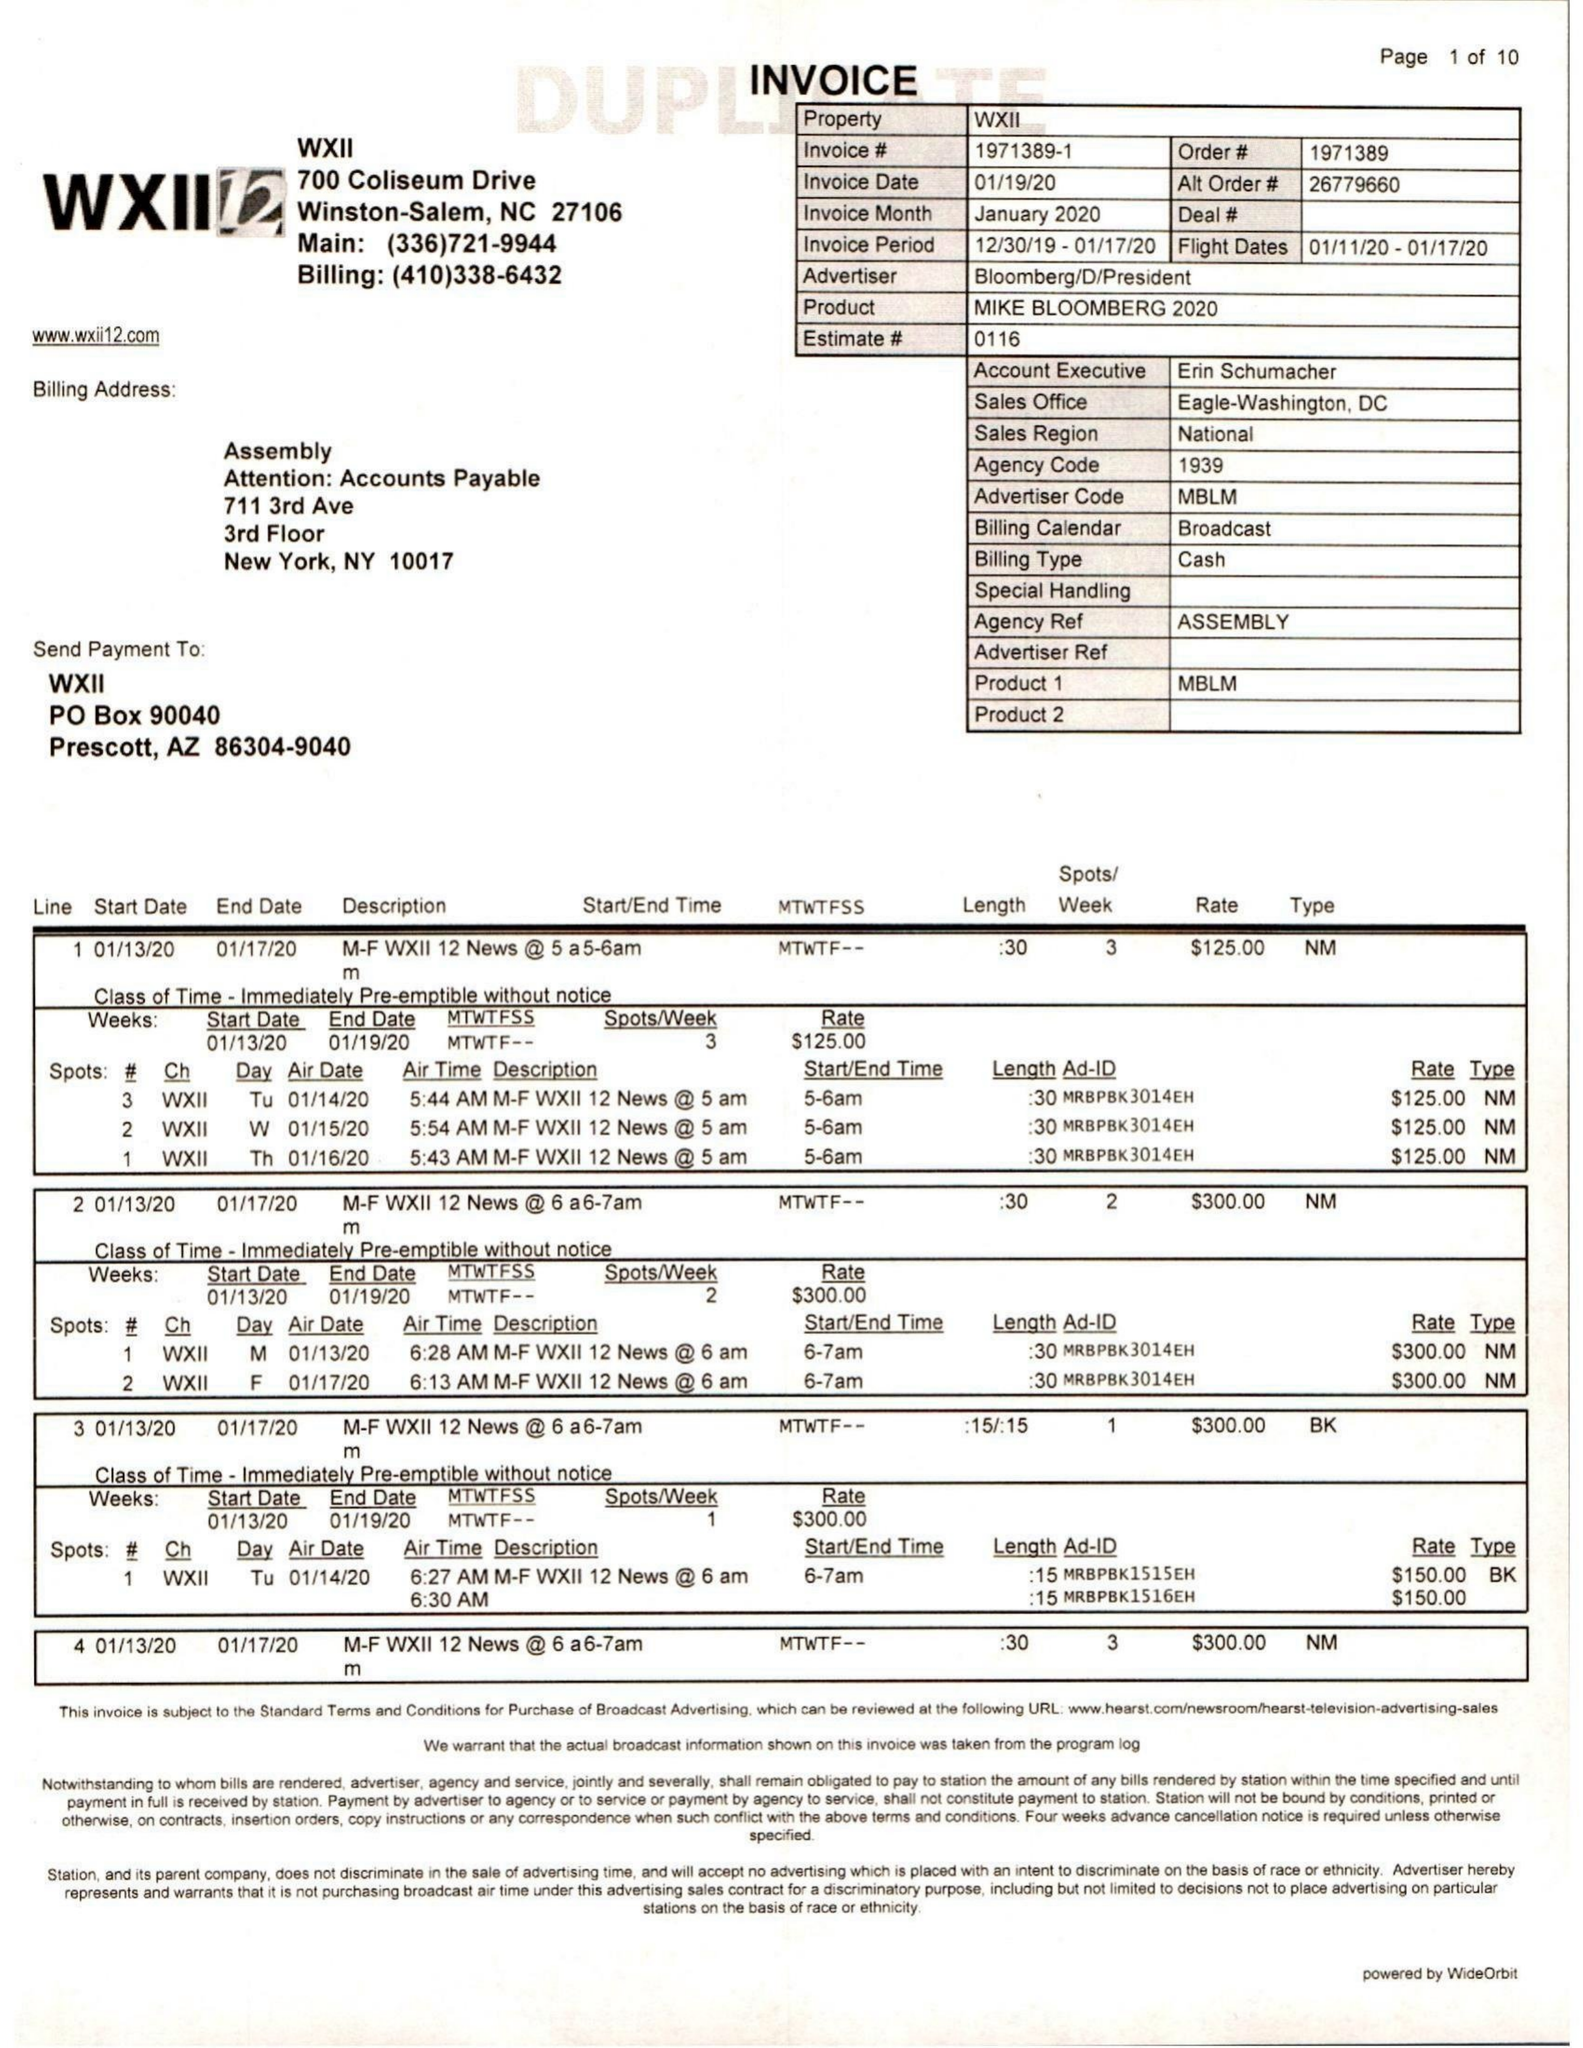What is the value for the flight_from?
Answer the question using a single word or phrase. 01/11/20 